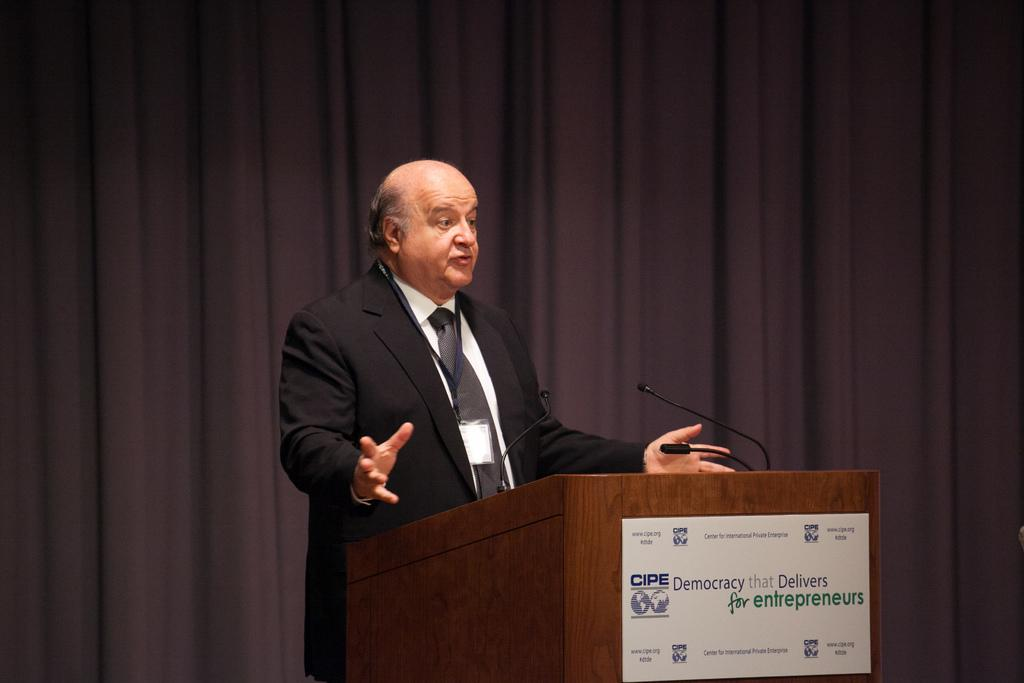What is the main subject of the image? There is a person standing in the center of the image. What is in front of the person? There is a wooden stand and a banner in front of the person. What equipment is visible in front of the person? Microphones are visible in front of the person. What can be seen in the background of the image? There is a curtain in the background of the image. What type of agreement is being signed by the person in the image? There is no indication of a signing or agreement in the image; it only shows a person standing in front of a wooden stand, banner, and microphones. How many hands does the person have in the image? The image only shows the person from the waist up, so it is impossible to determine the number of hands they have. 